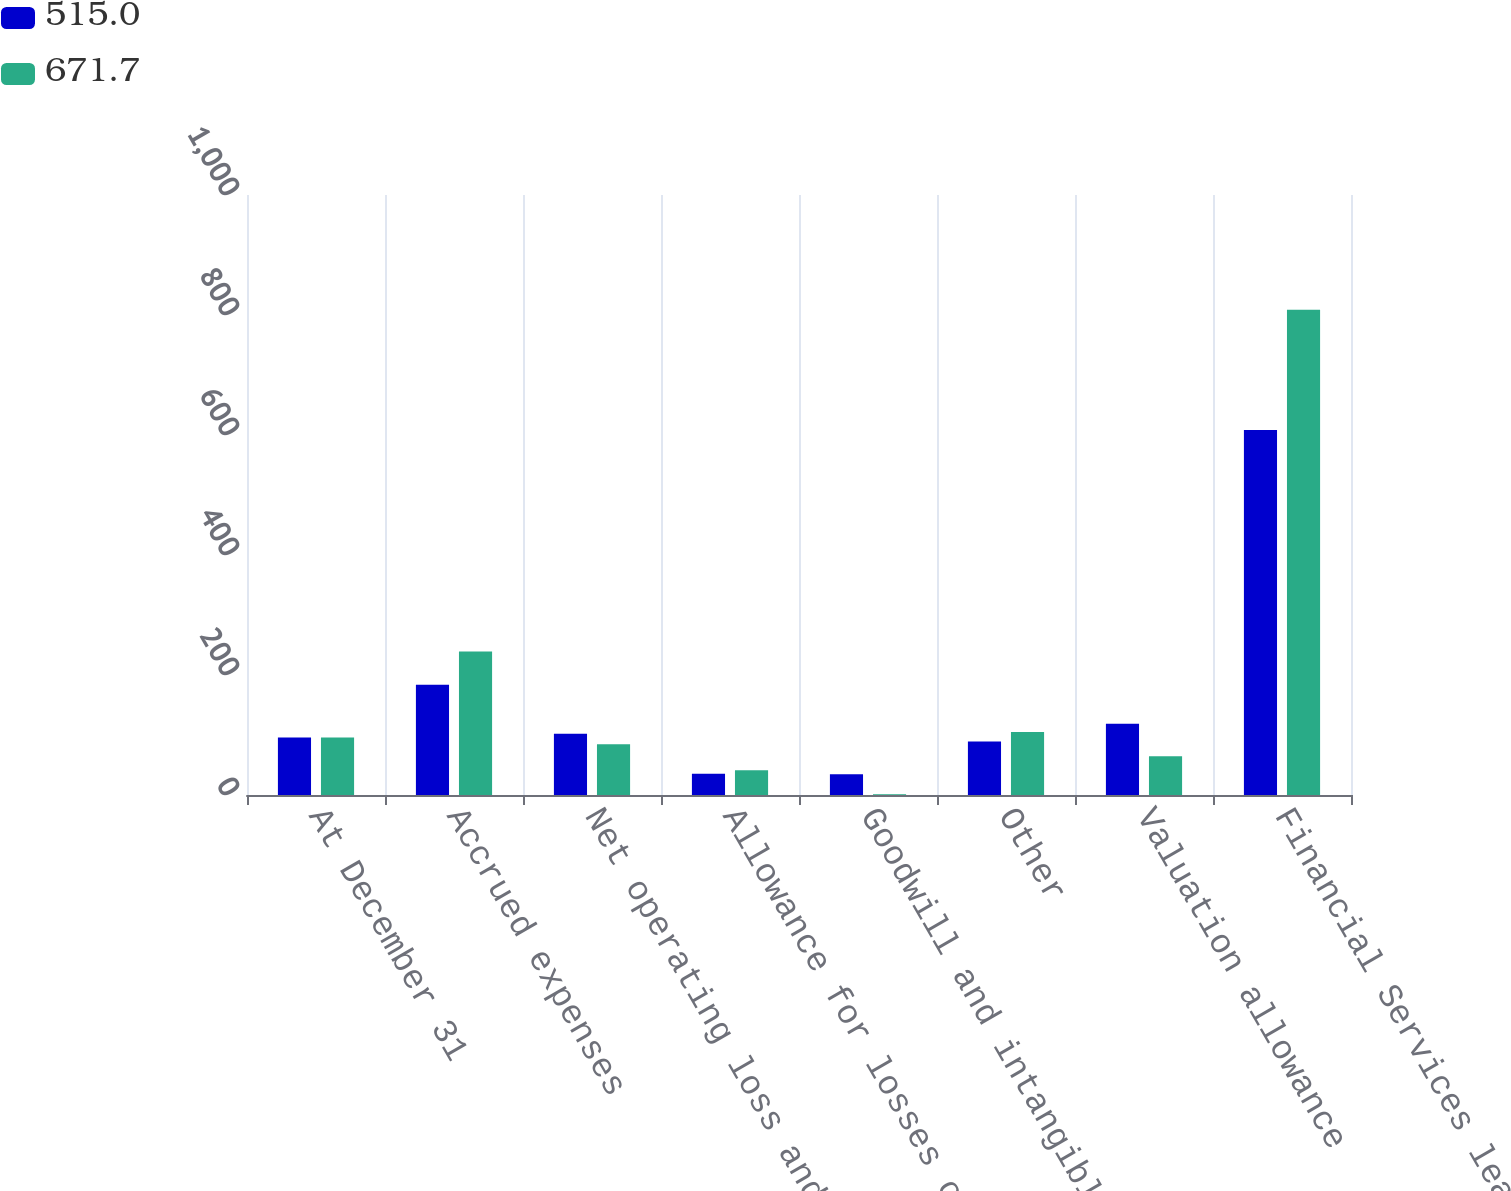<chart> <loc_0><loc_0><loc_500><loc_500><stacked_bar_chart><ecel><fcel>At December 31<fcel>Accrued expenses<fcel>Net operating loss and tax<fcel>Allowance for losses on<fcel>Goodwill and intangibles<fcel>Other<fcel>Valuation allowance<fcel>Financial Services leasing<nl><fcel>515<fcel>95.65<fcel>183.9<fcel>102.1<fcel>35.6<fcel>34.4<fcel>89.2<fcel>118.6<fcel>608.2<nl><fcel>671.7<fcel>95.65<fcel>239.2<fcel>84.4<fcel>41.2<fcel>1.3<fcel>105.1<fcel>64.5<fcel>808.7<nl></chart> 